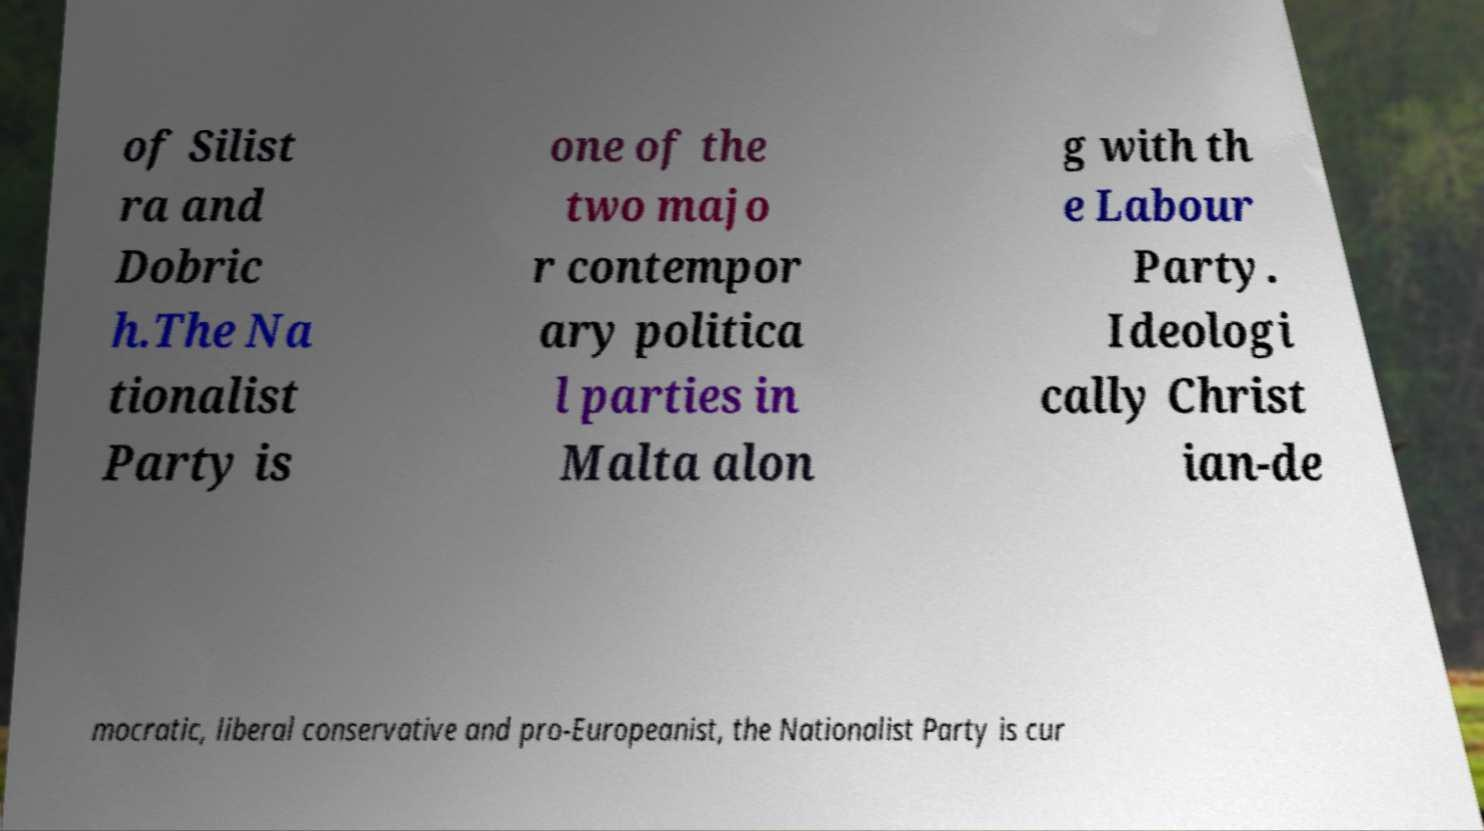What messages or text are displayed in this image? I need them in a readable, typed format. of Silist ra and Dobric h.The Na tionalist Party is one of the two majo r contempor ary politica l parties in Malta alon g with th e Labour Party. Ideologi cally Christ ian-de mocratic, liberal conservative and pro-Europeanist, the Nationalist Party is cur 